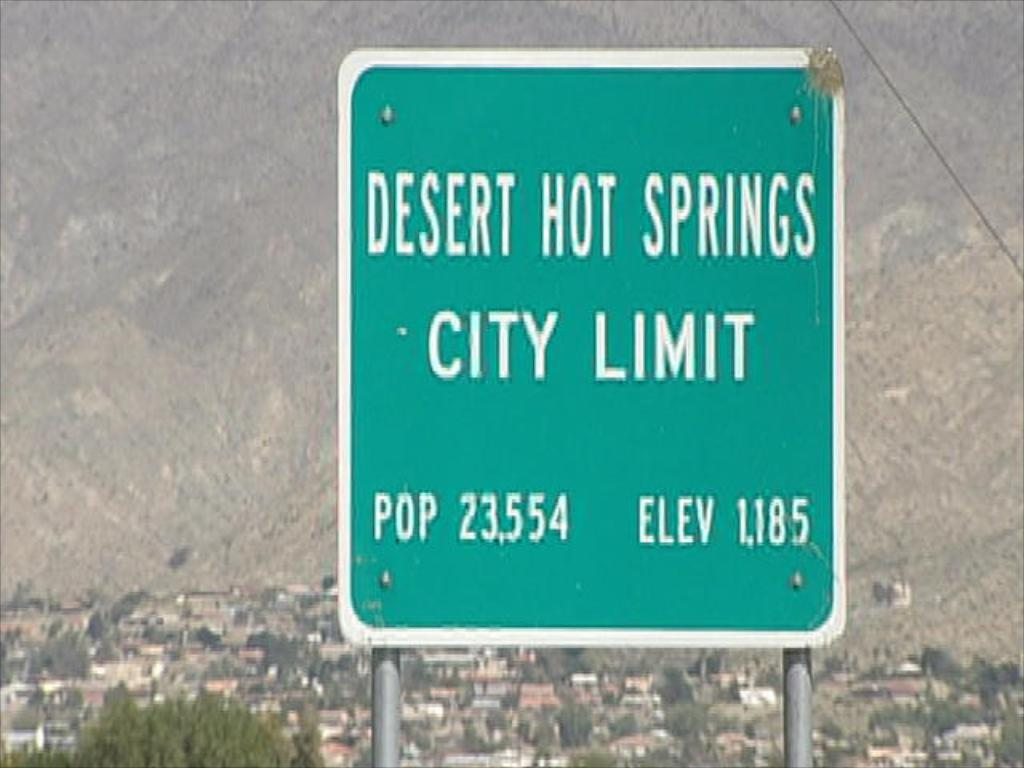<image>
Present a compact description of the photo's key features. A sign for Desert Hot Springs shows the elevation at 1,185. 